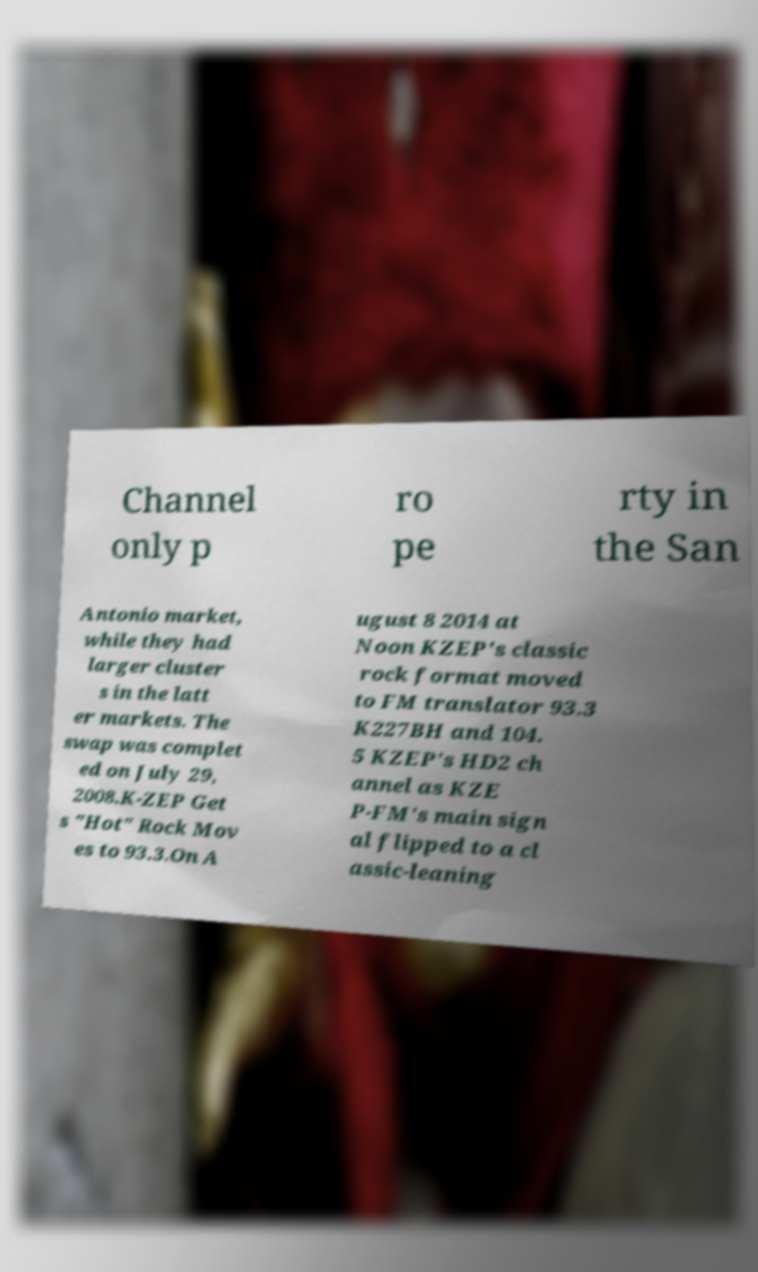There's text embedded in this image that I need extracted. Can you transcribe it verbatim? Channel only p ro pe rty in the San Antonio market, while they had larger cluster s in the latt er markets. The swap was complet ed on July 29, 2008.K-ZEP Get s "Hot" Rock Mov es to 93.3.On A ugust 8 2014 at Noon KZEP's classic rock format moved to FM translator 93.3 K227BH and 104. 5 KZEP's HD2 ch annel as KZE P-FM's main sign al flipped to a cl assic-leaning 